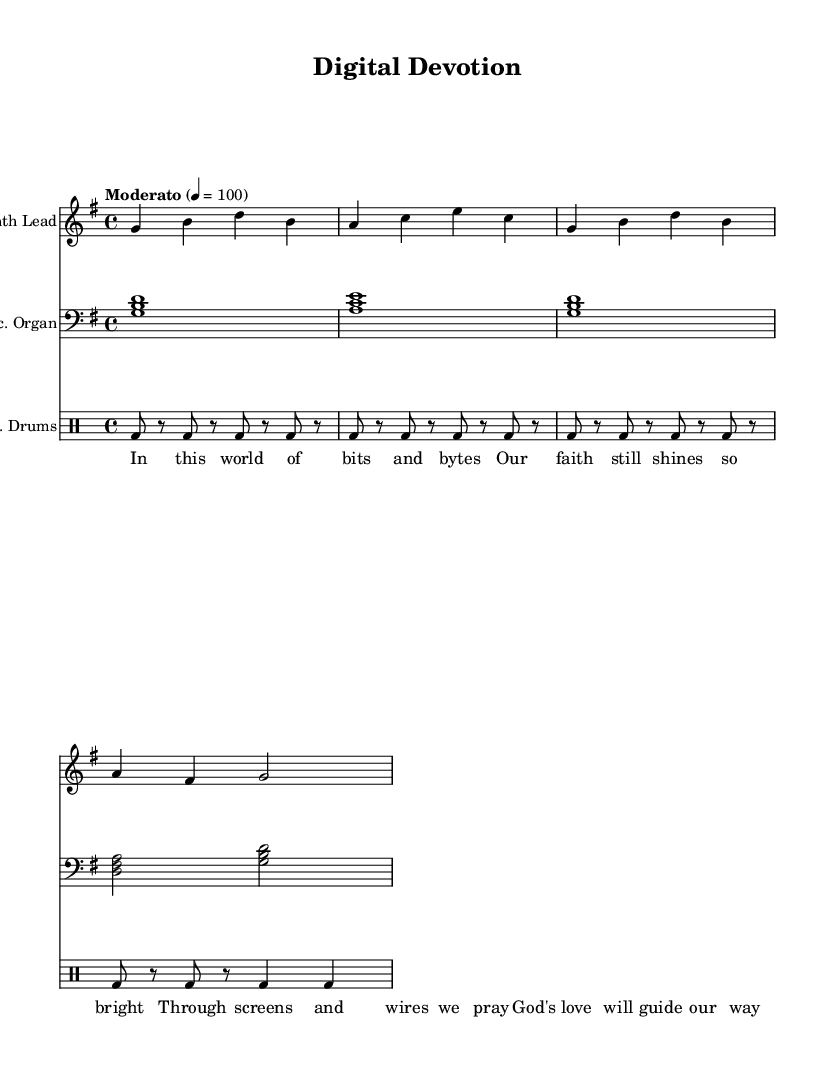What is the key signature of this music? The key signature is G major, which has one sharp (F#). You can identify this by looking at the key signature at the beginning of the staff.
Answer: G major What is the time signature of this score? The time signature is 4/4, which indicates there are four beats in a measure and the quarter note gets one beat. This can be seen right after the clef and key signature at the beginning of the score.
Answer: 4/4 What is the tempo marking for the piece? The tempo marking is Moderato, which suggests a moderate pace for the music. This is indicated above the staff where the tempo is specified.
Answer: Moderato How many measures are there in the synth lead? There are four measures in the synth lead. You can count the vertical lines that separate each measure in the staff to find the total number of measures.
Answer: 4 What is the main theme expressed in the lyrics? The main theme expressed in the lyrics is the brightness of faith in a digital world. This can be understood by reading through the lines of the verse, which talk about faith prevailing amidst technology.
Answer: Faith shines bright What type of instruments are used in this composition? The instruments used are a Synth Lead, Electronic Organ, and Electronic Drums. This information can be found labeled above each staff within the score section.
Answer: Synth Lead, Electronic Organ, Electronic Drums What poetic form is used in the lyrics? The poetic form is quatrains, as the lyrics consist of four lines that express a complete thought or idea. You can see this structure in the lyrics section where each line is a part of a stanza.
Answer: Quatrains 